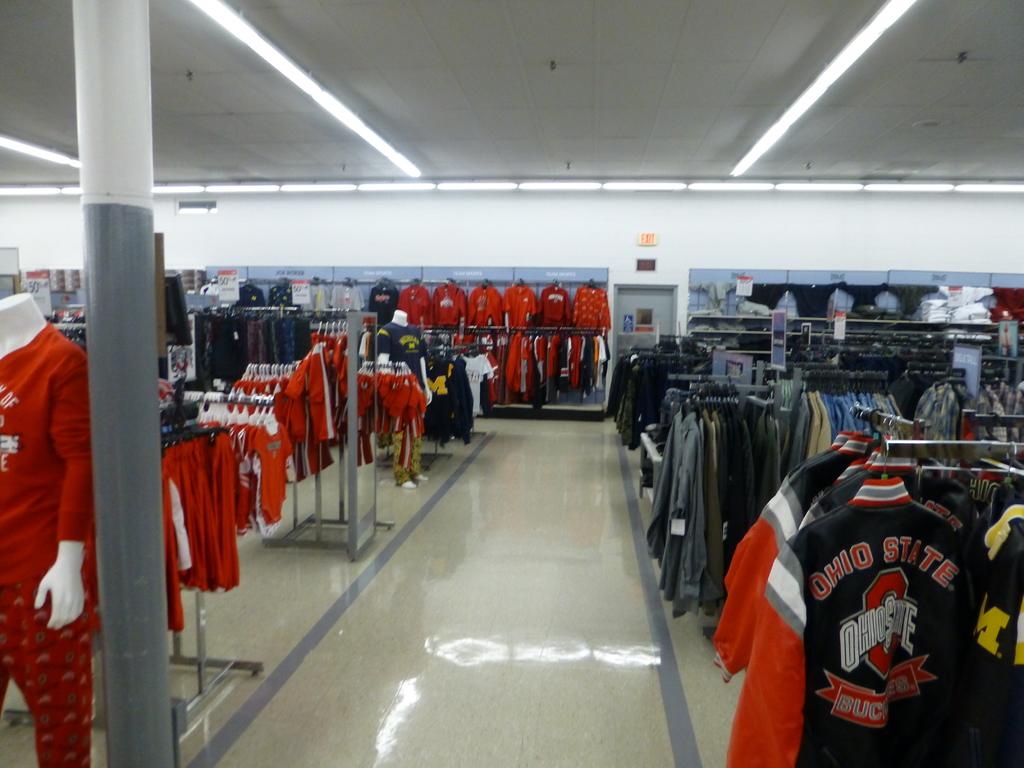What team does the jacket have on it?
Your response must be concise. Ohio state. What letter can be seen in yellow, on one of the clothes?
Your answer should be compact. M. 